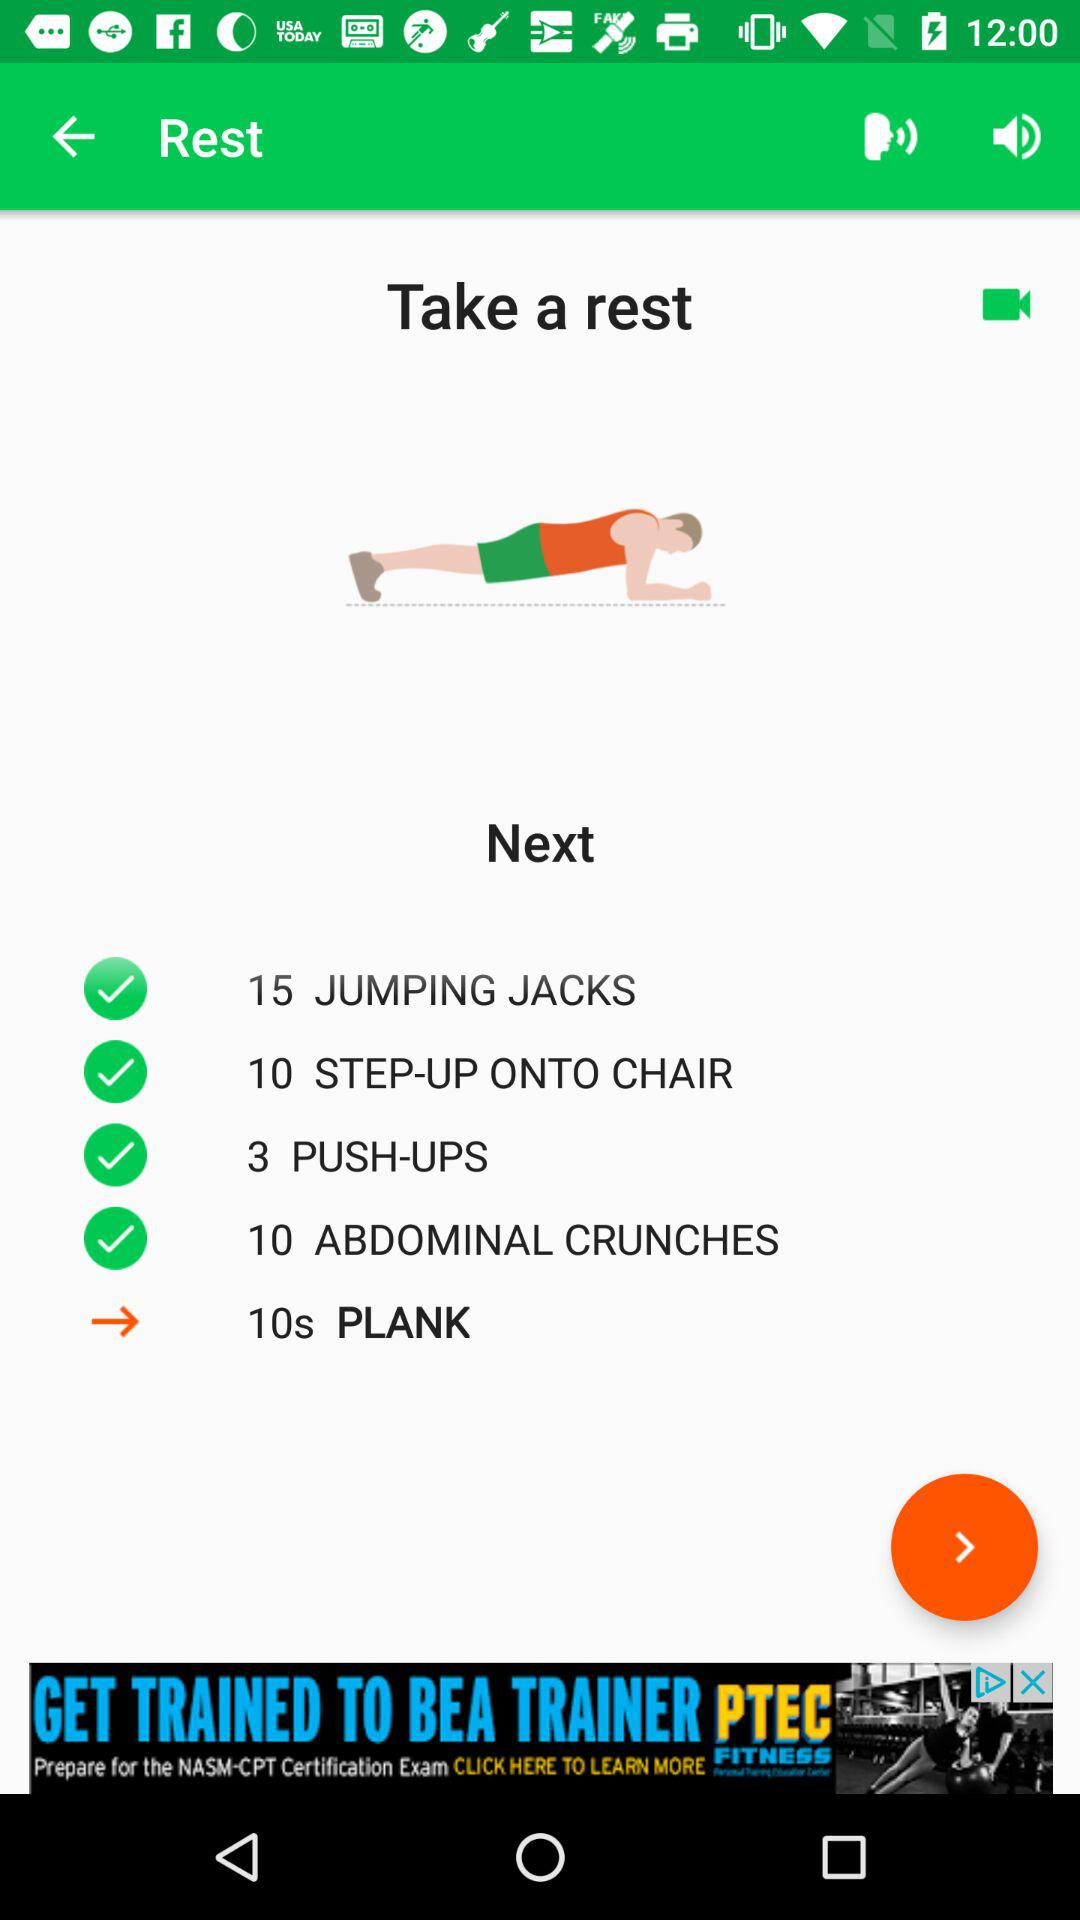How many abdominal crunches are there?
Answer the question using a single word or phrase. 10 